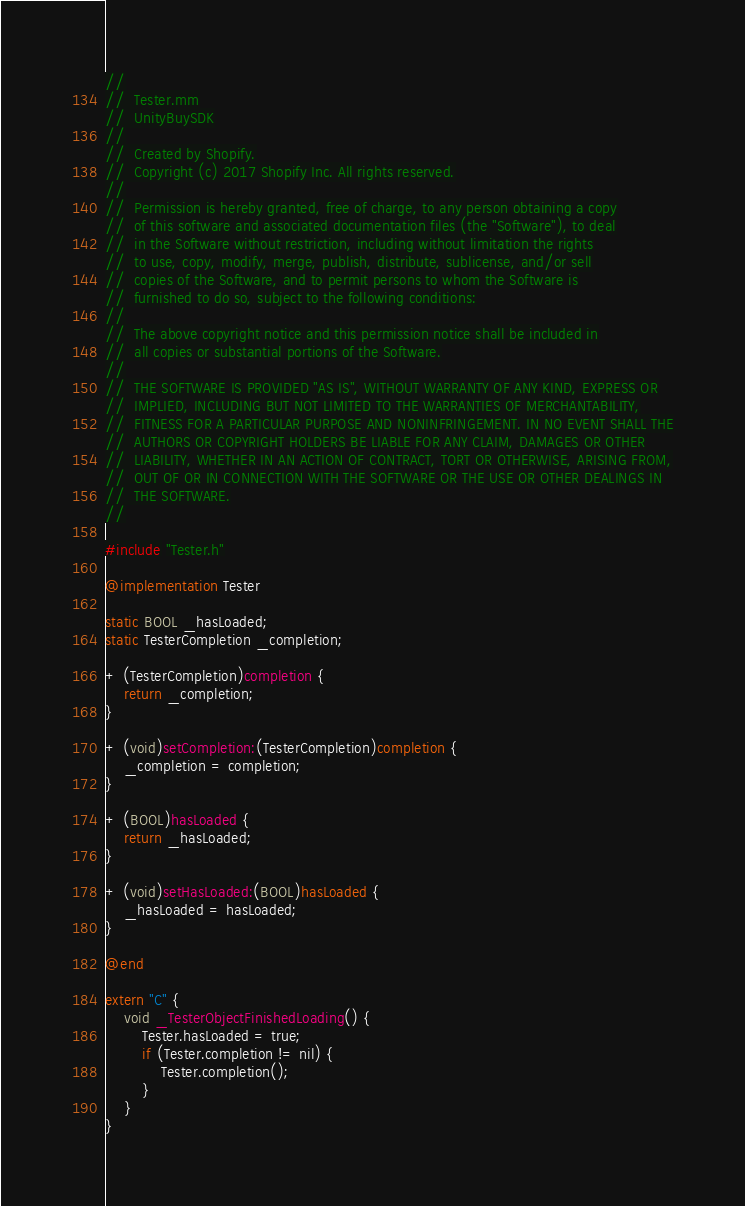<code> <loc_0><loc_0><loc_500><loc_500><_ObjectiveC_>//
//  Tester.mm
//  UnityBuySDK
//
//  Created by Shopify.
//  Copyright (c) 2017 Shopify Inc. All rights reserved.
//
//  Permission is hereby granted, free of charge, to any person obtaining a copy
//  of this software and associated documentation files (the "Software"), to deal
//  in the Software without restriction, including without limitation the rights
//  to use, copy, modify, merge, publish, distribute, sublicense, and/or sell
//  copies of the Software, and to permit persons to whom the Software is
//  furnished to do so, subject to the following conditions:
//
//  The above copyright notice and this permission notice shall be included in
//  all copies or substantial portions of the Software.
//
//  THE SOFTWARE IS PROVIDED "AS IS", WITHOUT WARRANTY OF ANY KIND, EXPRESS OR
//  IMPLIED, INCLUDING BUT NOT LIMITED TO THE WARRANTIES OF MERCHANTABILITY,
//  FITNESS FOR A PARTICULAR PURPOSE AND NONINFRINGEMENT. IN NO EVENT SHALL THE
//  AUTHORS OR COPYRIGHT HOLDERS BE LIABLE FOR ANY CLAIM, DAMAGES OR OTHER
//  LIABILITY, WHETHER IN AN ACTION OF CONTRACT, TORT OR OTHERWISE, ARISING FROM,
//  OUT OF OR IN CONNECTION WITH THE SOFTWARE OR THE USE OR OTHER DEALINGS IN
//  THE SOFTWARE.
//

#include "Tester.h"

@implementation Tester

static BOOL _hasLoaded;
static TesterCompletion _completion;

+ (TesterCompletion)completion {
    return _completion;
}

+ (void)setCompletion:(TesterCompletion)completion {
    _completion = completion;
}

+ (BOOL)hasLoaded {
    return _hasLoaded;
}

+ (void)setHasLoaded:(BOOL)hasLoaded {
    _hasLoaded = hasLoaded;
}

@end

extern "C" {
    void _TesterObjectFinishedLoading() {
        Tester.hasLoaded = true;
        if (Tester.completion != nil) {
            Tester.completion();
        }
    }
}
</code> 